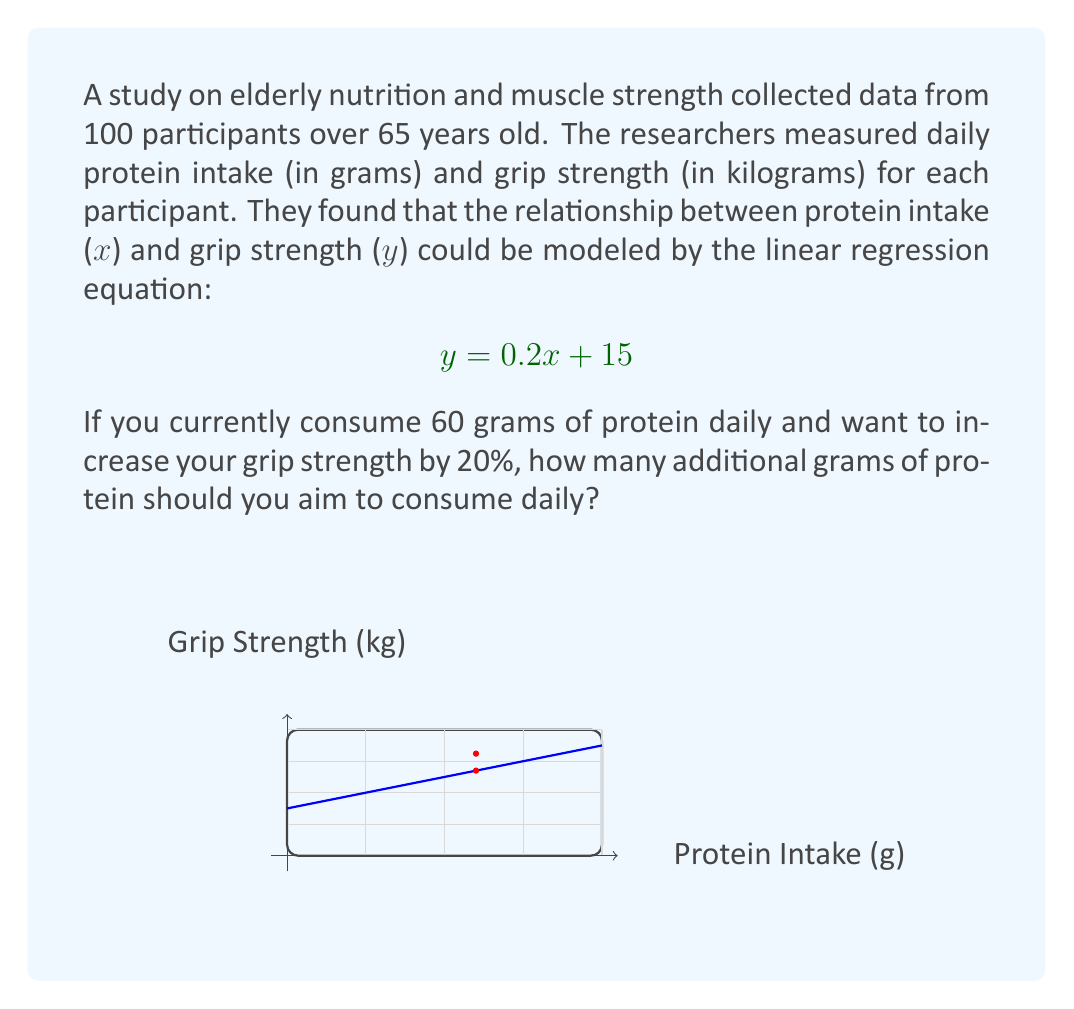Teach me how to tackle this problem. Let's approach this step-by-step:

1) First, we need to calculate your current grip strength based on your protein intake:
   $y = 0.2x + 15$, where $x = 60$
   $y = 0.2(60) + 15 = 12 + 15 = 27$ kg

2) We want to increase this by 20%. Let's calculate the target grip strength:
   Target strength = Current strength * 1.2
   $27 * 1.2 = 32.4$ kg

3) Now, we need to find the protein intake (x) that corresponds to this new grip strength (y):
   $32.4 = 0.2x + 15$

4) Solve for x:
   $32.4 - 15 = 0.2x$
   $17.4 = 0.2x$
   $x = 17.4 / 0.2 = 87$ grams

5) The question asks for additional grams of protein:
   Additional protein = New intake - Current intake
   $87 - 60 = 27$ grams

Therefore, you should aim to consume an additional 27 grams of protein daily to increase your grip strength by 20%.
Answer: 27 grams 